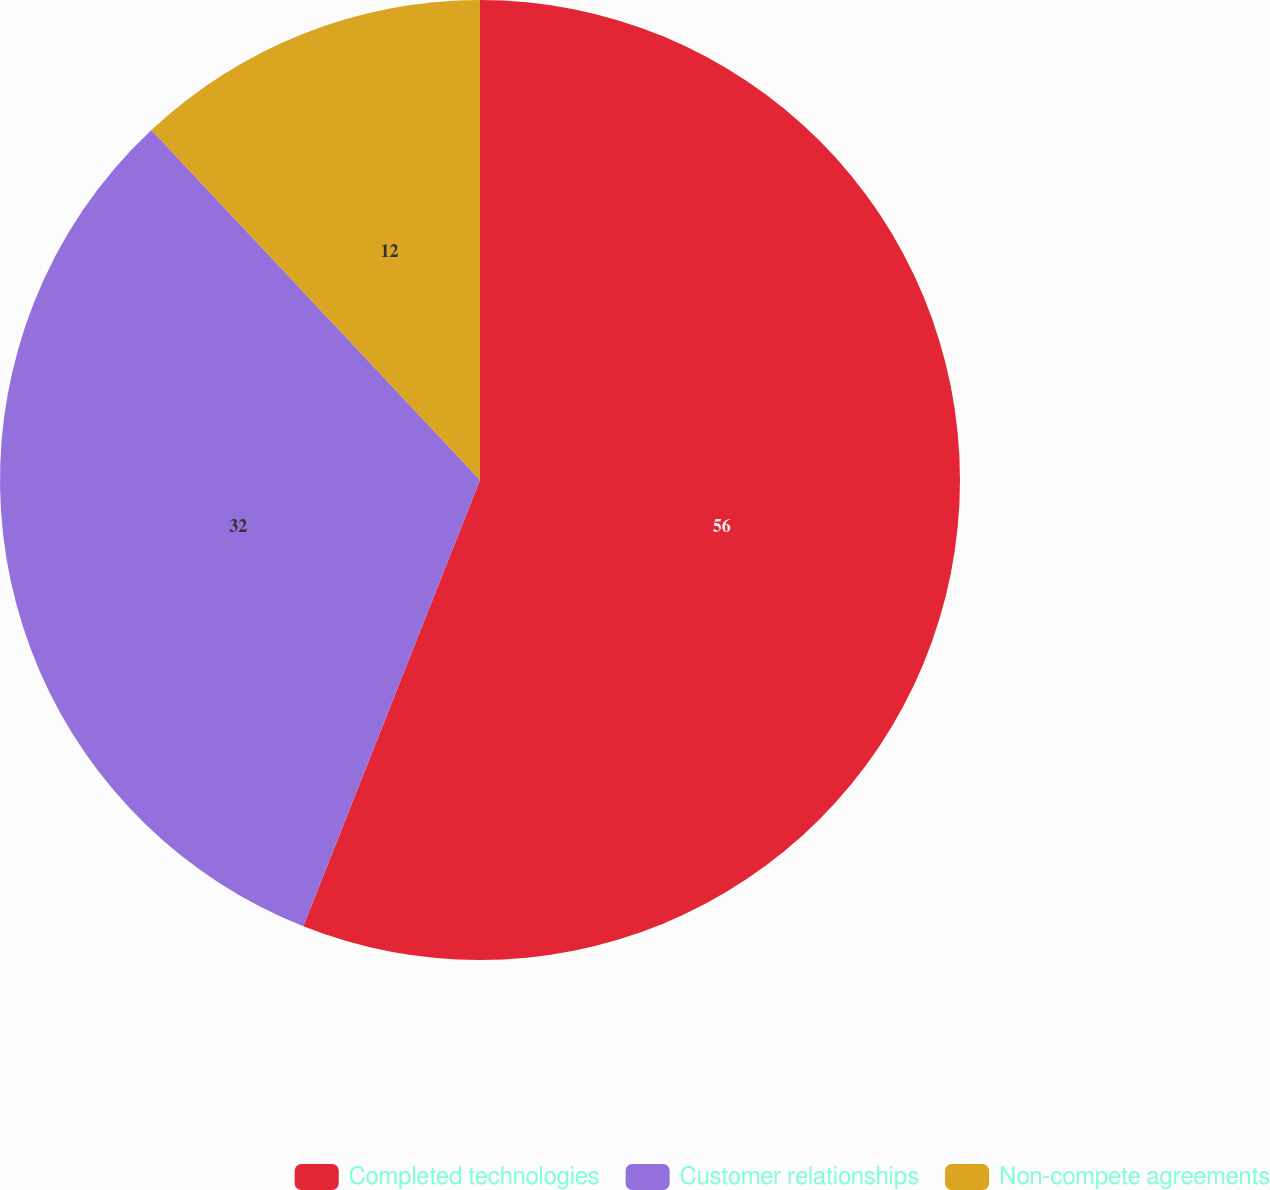Convert chart to OTSL. <chart><loc_0><loc_0><loc_500><loc_500><pie_chart><fcel>Completed technologies<fcel>Customer relationships<fcel>Non-compete agreements<nl><fcel>56.0%<fcel>32.0%<fcel>12.0%<nl></chart> 